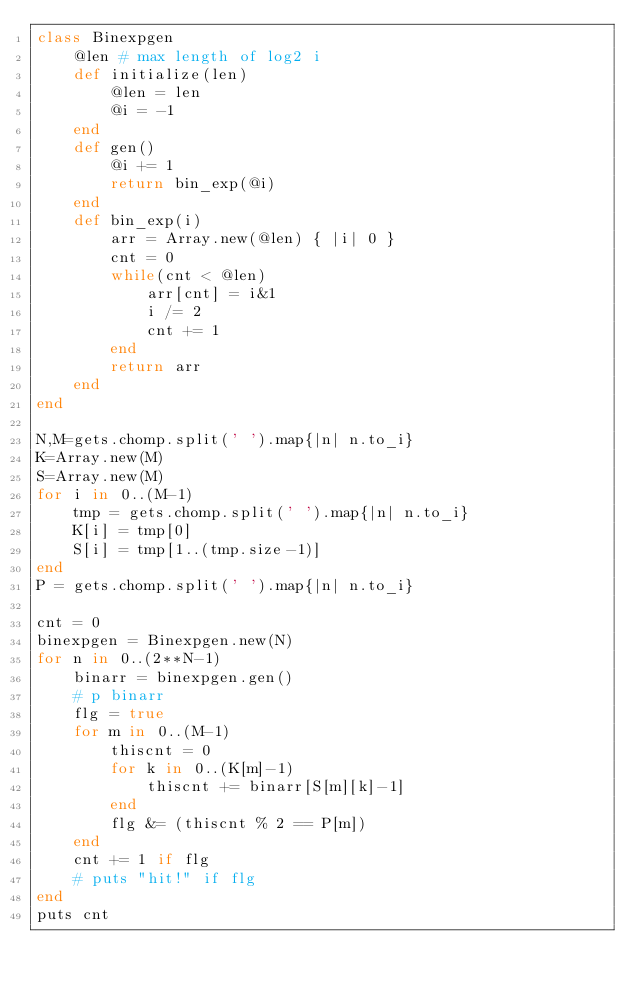<code> <loc_0><loc_0><loc_500><loc_500><_Ruby_>class Binexpgen
	@len # max length of log2 i
	def initialize(len)
		@len = len
		@i = -1
	end
	def gen()
		@i += 1
		return bin_exp(@i)
	end
	def bin_exp(i)
		arr = Array.new(@len) { |i| 0 }
		cnt = 0
		while(cnt < @len)
			arr[cnt] = i&1
			i /= 2
			cnt += 1
		end
		return arr
	end
end

N,M=gets.chomp.split(' ').map{|n| n.to_i}
K=Array.new(M)
S=Array.new(M)
for i in 0..(M-1)
	tmp = gets.chomp.split(' ').map{|n| n.to_i}
	K[i] = tmp[0]
	S[i] = tmp[1..(tmp.size-1)]
end
P = gets.chomp.split(' ').map{|n| n.to_i}

cnt = 0
binexpgen = Binexpgen.new(N)
for n in 0..(2**N-1)
	binarr = binexpgen.gen()
	# p binarr
	flg = true
	for m in 0..(M-1)
		thiscnt = 0
		for k in 0..(K[m]-1)
			thiscnt += binarr[S[m][k]-1]
		end
		flg &= (thiscnt % 2 == P[m])
	end
	cnt += 1 if flg
	# puts "hit!" if flg
end
puts cnt

</code> 